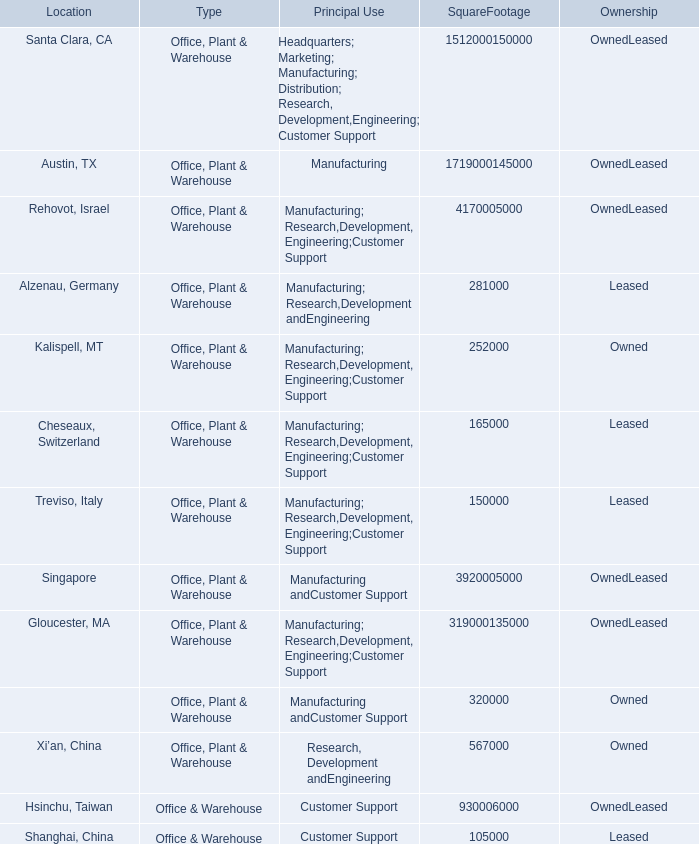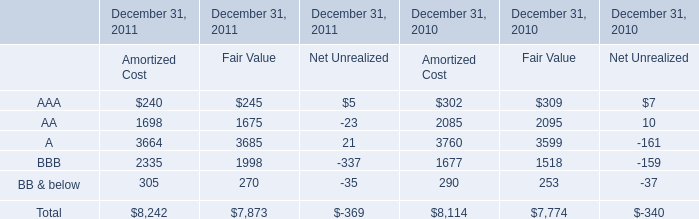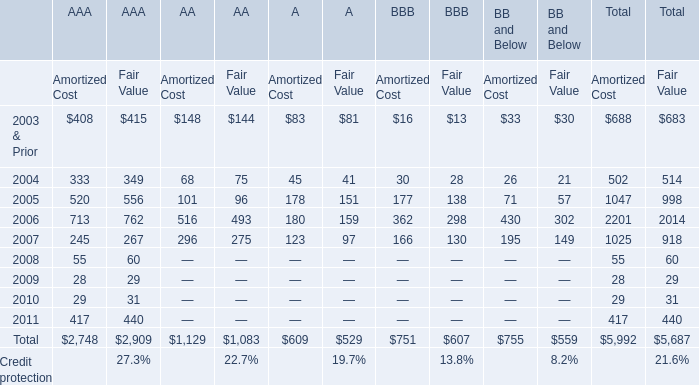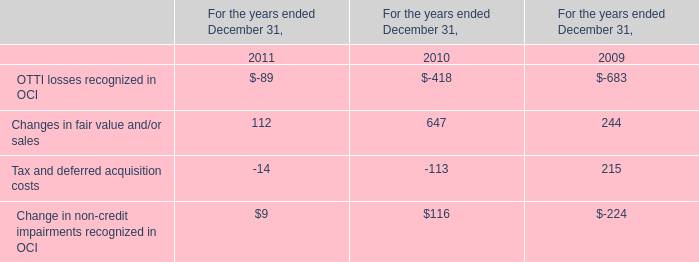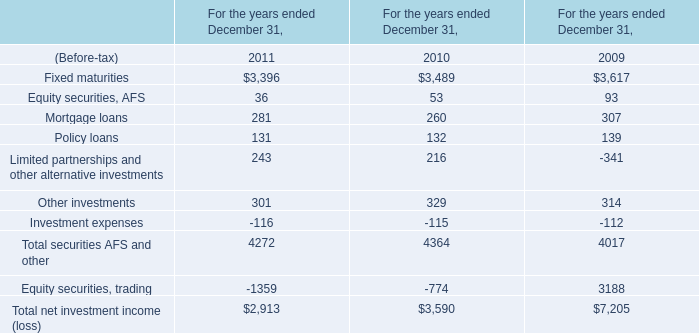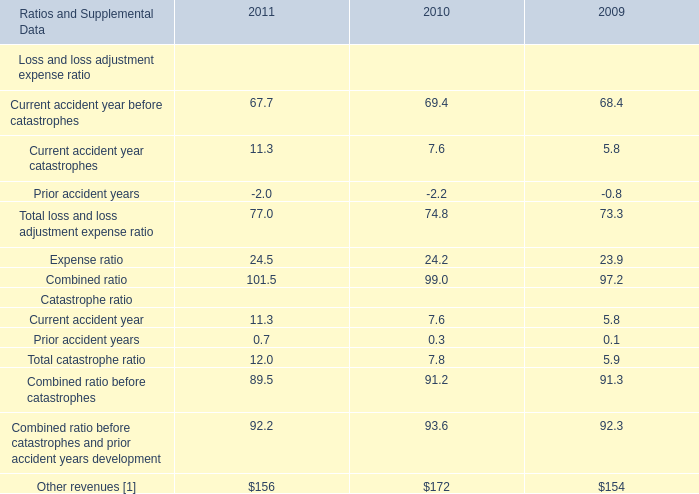What's the average of Kalispell, MT of SquareFootage 1,512,000150,000, and A of December 31, 2010 Amortized Cost ? 
Computations: ((252000.0 + 3760.0) / 2)
Answer: 127880.0. 